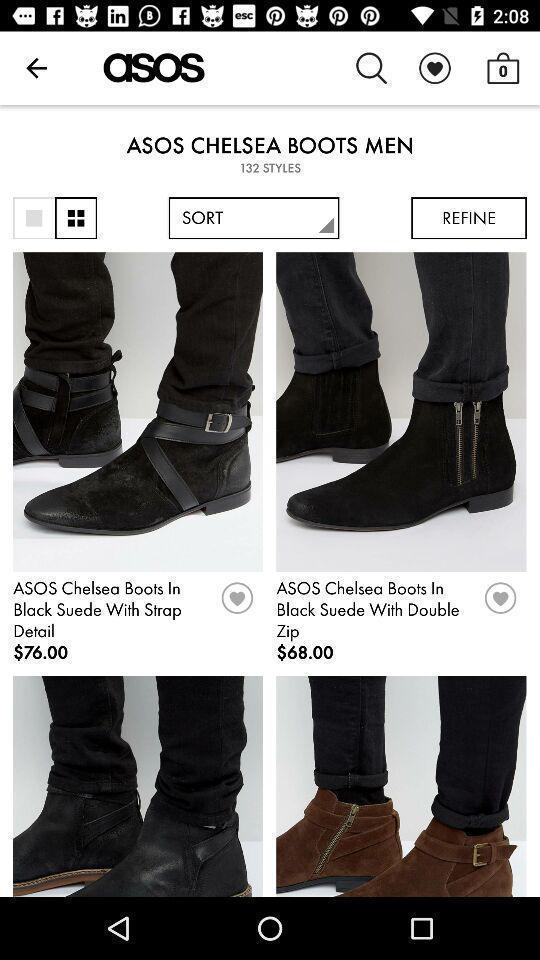Tell me what you see in this picture. Page displaying shoes for sale in an ecommerce app. 